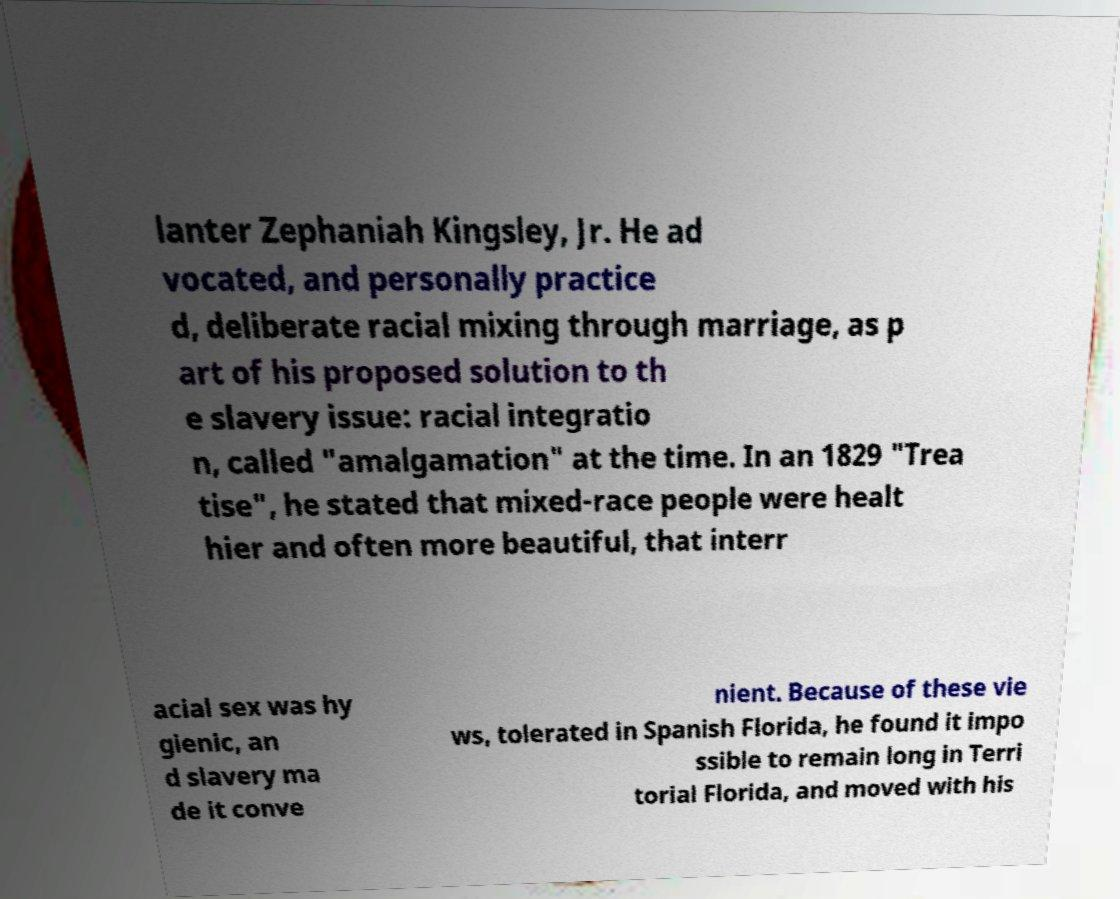Can you accurately transcribe the text from the provided image for me? lanter Zephaniah Kingsley, Jr. He ad vocated, and personally practice d, deliberate racial mixing through marriage, as p art of his proposed solution to th e slavery issue: racial integratio n, called "amalgamation" at the time. In an 1829 "Trea tise", he stated that mixed-race people were healt hier and often more beautiful, that interr acial sex was hy gienic, an d slavery ma de it conve nient. Because of these vie ws, tolerated in Spanish Florida, he found it impo ssible to remain long in Terri torial Florida, and moved with his 